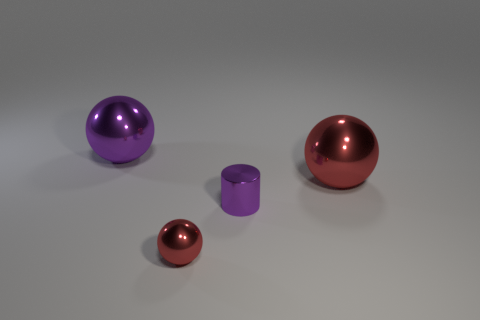How many other small objects are the same shape as the tiny purple object? Upon reviewing the image, there are no other objects that precisely match the shape of the tiny purple cylinder. However, if we consider the color, not just the shape, the larger purple sphere shares the same hue but not the same form. 